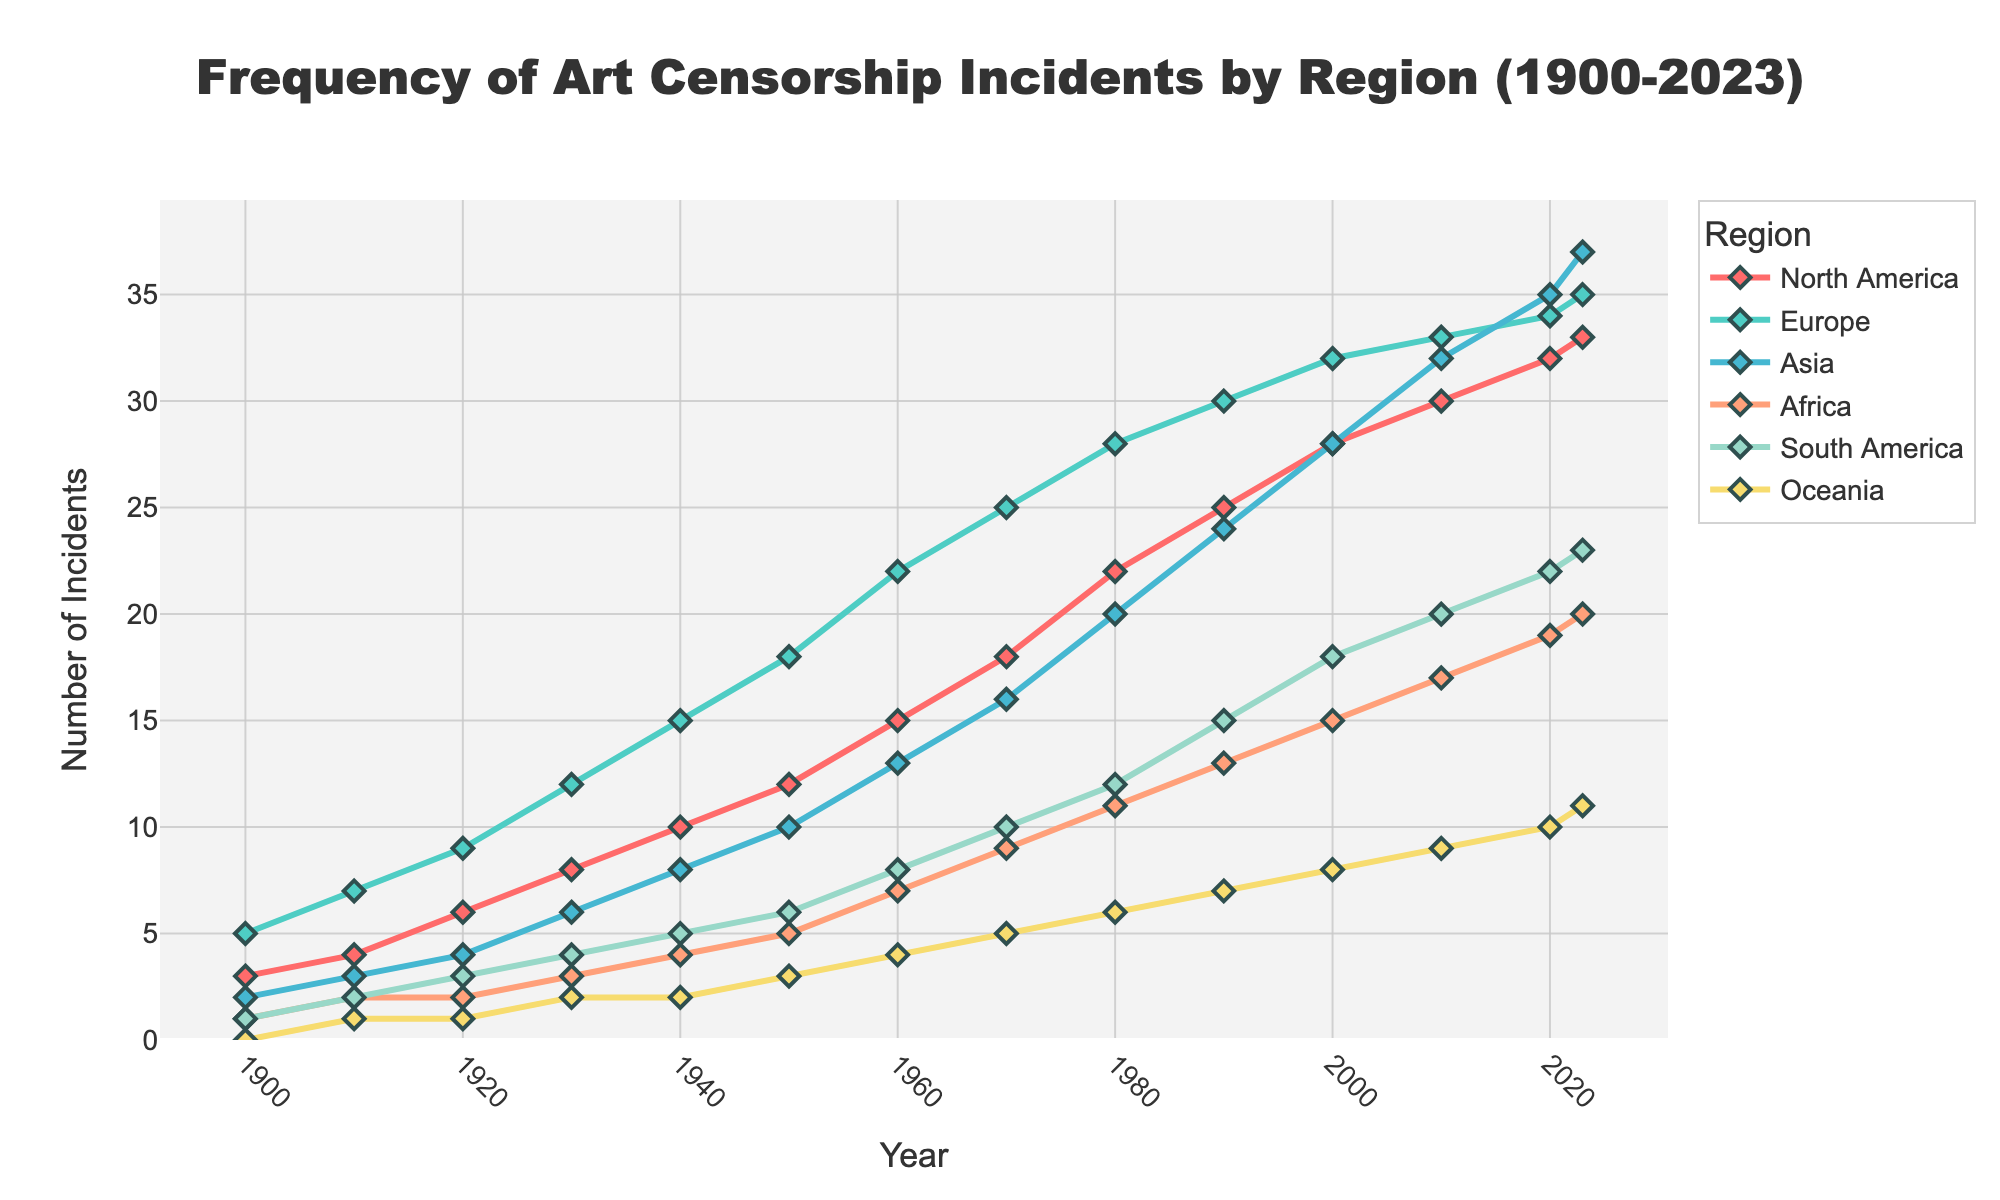Which region shows the highest number of art censorship incidents in 2023? Checking each region's value in 2023, Oceania has 11 incidents, South America has 23, Africa has 20, Asia has 37, Europe has 35, and North America has 33. Asia's 37 incidents are the highest.
Answer: Asia How has the frequency of art censorship incidents in North America changed from 1900 to 2023? In 1900, North America had 3 incidents, and in 2023 it has 33 incidents. The frequency increased by 33 - 3 = 30 incidents over 123 years.
Answer: Increased by 30 incidents Compare the number of art censorship incidents between Europe and Africa in 1940. Which region had more, and by how many? In 1940, Europe had 15 incidents whereas Africa had 4. The difference is 15 - 4 = 11 incidents, with Europe having more.
Answer: Europe by 11 incidents During which decade does South America see the most noticeable rise in art censorship incidents? Observing the data, South America's incidents rose significantly from 10 in 1970 to 12 in 1980 (an increase of 2), but the most noticeable rise is from 15 in 1990 to 18 in 2000 (an increase of 3).
Answer: 1990 to 2000 What is the average number of art censorship incidents in Oceania from 1950 to 2000? The incidents from 1950 to 2000 are 3, 4, 5, 6, 7, 8. Sum them: 3+4+5+6+7+8=33. Average is 33/6 = 5.5
Answer: 5.5 Which region shows the least number of art censorship incidents in 2010 and by how many compared to the most affected region in the same year? In 2010, Oceania has 9 incidents, the least. Asia has the most with 32 incidents. The difference is 32 - 9 = 23 incidents.
Answer: Oceania by 23 incidents Has North America or Europe seen a greater increase in art censorship incidents from 1900 to 2023? North America's increase is 33 - 3 = 30, and Europe's is 35 - 5 = 30. Both have seen an equal increase of 30 incidents.
Answer: Equal increase of 30 incidents What is the total number of art censorship incidents across all regions in the year 2000? Sum of incidents in 2000: 28+32+28+15+18+8 = 129
Answer: 129 How do the art censorship incidents in Asia compare with those in South America in 1980? In 1980, Asia had 20 incidents and South America had 12. Asia had 8 more incidents than South America.
Answer: Asia by 8 incidents Describe the trend in the number of art censorship incidents in Africa from 1900 to 2023. Starting from 1 in 1900, Africa saw a steady increase to 20 in 2023.
Answer: Steady increase 